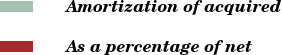<chart> <loc_0><loc_0><loc_500><loc_500><pie_chart><fcel>Amortization of acquired<fcel>As a percentage of net<nl><fcel>100.0%<fcel>0.0%<nl></chart> 